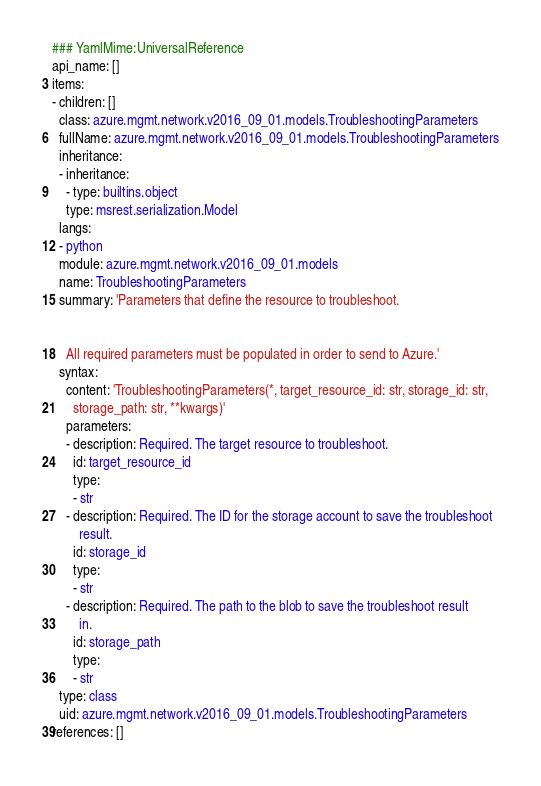<code> <loc_0><loc_0><loc_500><loc_500><_YAML_>### YamlMime:UniversalReference
api_name: []
items:
- children: []
  class: azure.mgmt.network.v2016_09_01.models.TroubleshootingParameters
  fullName: azure.mgmt.network.v2016_09_01.models.TroubleshootingParameters
  inheritance:
  - inheritance:
    - type: builtins.object
    type: msrest.serialization.Model
  langs:
  - python
  module: azure.mgmt.network.v2016_09_01.models
  name: TroubleshootingParameters
  summary: 'Parameters that define the resource to troubleshoot.


    All required parameters must be populated in order to send to Azure.'
  syntax:
    content: 'TroubleshootingParameters(*, target_resource_id: str, storage_id: str,
      storage_path: str, **kwargs)'
    parameters:
    - description: Required. The target resource to troubleshoot.
      id: target_resource_id
      type:
      - str
    - description: Required. The ID for the storage account to save the troubleshoot
        result.
      id: storage_id
      type:
      - str
    - description: Required. The path to the blob to save the troubleshoot result
        in.
      id: storage_path
      type:
      - str
  type: class
  uid: azure.mgmt.network.v2016_09_01.models.TroubleshootingParameters
references: []
</code> 